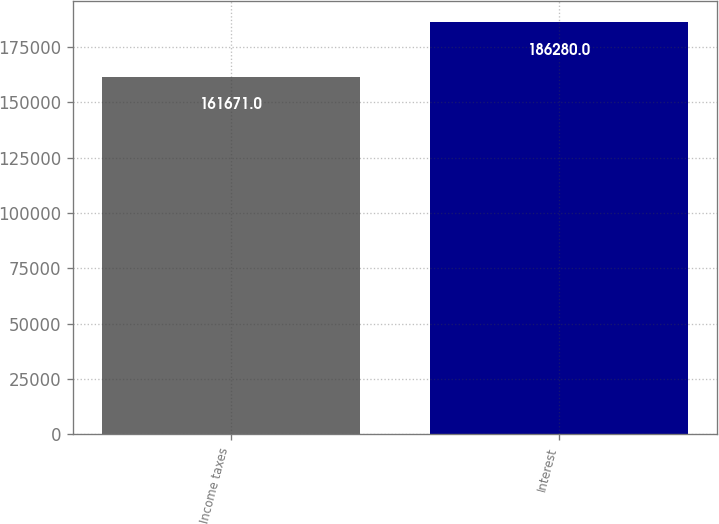<chart> <loc_0><loc_0><loc_500><loc_500><bar_chart><fcel>Income taxes<fcel>Interest<nl><fcel>161671<fcel>186280<nl></chart> 